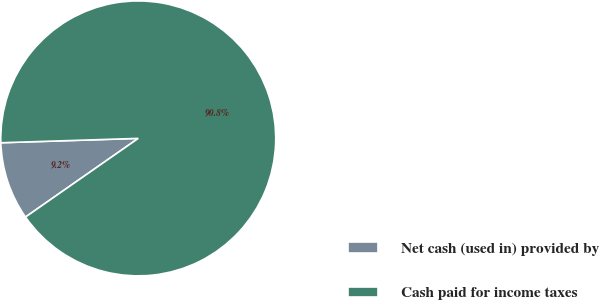Convert chart to OTSL. <chart><loc_0><loc_0><loc_500><loc_500><pie_chart><fcel>Net cash (used in) provided by<fcel>Cash paid for income taxes<nl><fcel>9.19%<fcel>90.81%<nl></chart> 